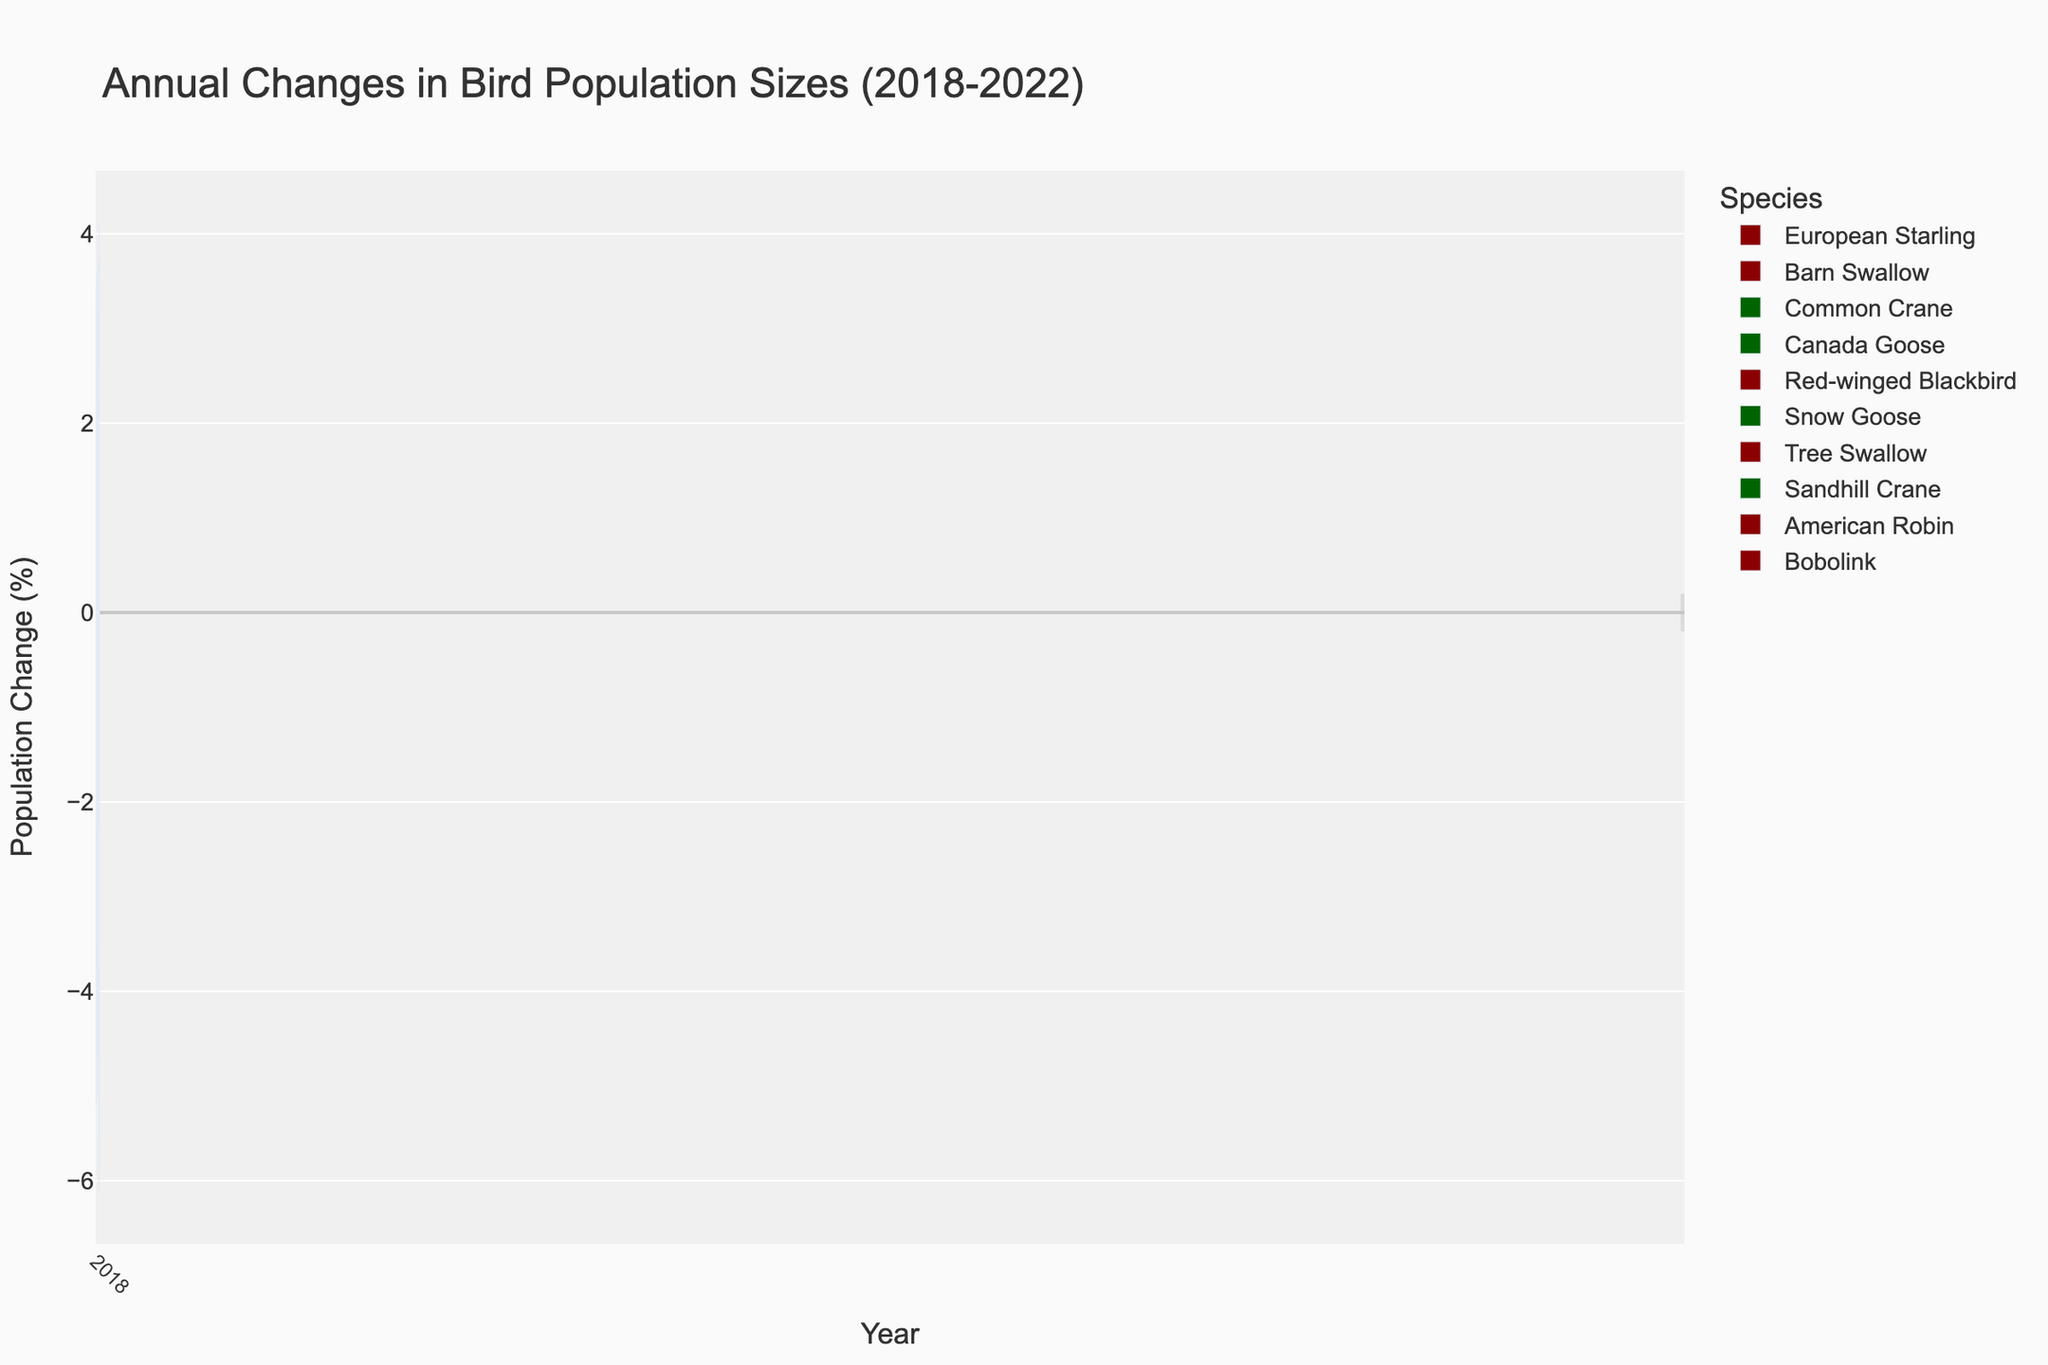What species shows a consistent increase in population size every year? By observing the color and height of the bars, which are green and positive for increasing populations, we see that the Common Crane, Canada Goose, Snow Goose, and Sandhill Crane all show consistent increases every year.
Answer: Common Crane, Canada Goose, Snow Goose, Sandhill Crane Which species had the biggest decline in population size in 2022? To determine this, we look at the red bars for 2022 and compare their lengths (absolute values). The European Starling shows the largest decline at -6.1%.
Answer: European Starling Compare the population changes of the American Robin and Tree Swallow in 2021. Which one had a larger decline? By comparing the red bars for 2021, the American Robin shows a change of -1.6% while the Tree Swallow shows -2.6%. The Tree Swallow had a larger decline.
Answer: Tree Swallow What is the average population change for the Belgian Songbirds in these datasets from 2018 to 2022? No data is provided for Belgian Songbirds, so there are no values to average.
Answer: No data Which species had the smallest change (positive or negative) in population size in 2020? By comparing the absolute values of the bars in 2020, we see the smallest change is for the Common Crane with a change of 2.9%.
Answer: Common Crane Are there any species that show both positive and negative population changes over the years? Observing the colors (green for positive and red for negative), only species with consistently one color across all bars for each year show consistent changes. European Starling, Barn Swallow, Common Crane, etc., show either positive or negative changes consistently but not both.
Answer: No species show both Which species had a better population increase trend, Canada Goose or Snow Goose? To determine this, compare the heights and colors of the bars for Canada Goose and Snow Goose over the years. Both species have positive population changes, but Snow Goose has a more significant increase each year, ranging from 3.2% to 4.1%, while the Canada Goose ranges from 1.9% to 2.7%.
Answer: Snow Goose What is the general trend observed for the Red-winged Blackbird population from 2018 to 2022? Looking at the red bars for Red-winged Blackbird from 2018 to 2022, the trend shows a gradual decline from -2.1% to -2.9%.
Answer: Gradual decline Which year showed the highest population increase for Sandhill Crane? By comparing the green bars for the Sandhill Crane, 2022 shows the highest population increase with a positive change of 2.6%.
Answer: 2022 What is the combined increase or decrease in population size for Bobolink over the five years? Sum up the values of Bobolink from 2018 to 2022: -4.3 + (-4.7) + (-5.1) + (-5.5) + (-5.9) = -25.5%. So, the combined decrease is -25.5%.
Answer: -25.5% 